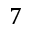Convert formula to latex. <formula><loc_0><loc_0><loc_500><loc_500>7</formula> 